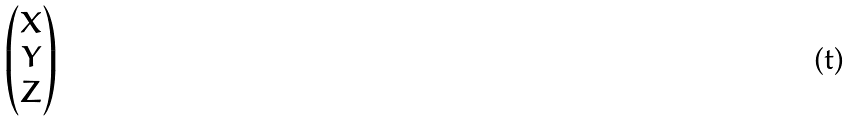<formula> <loc_0><loc_0><loc_500><loc_500>\begin{pmatrix} X \\ Y \\ Z \end{pmatrix}</formula> 